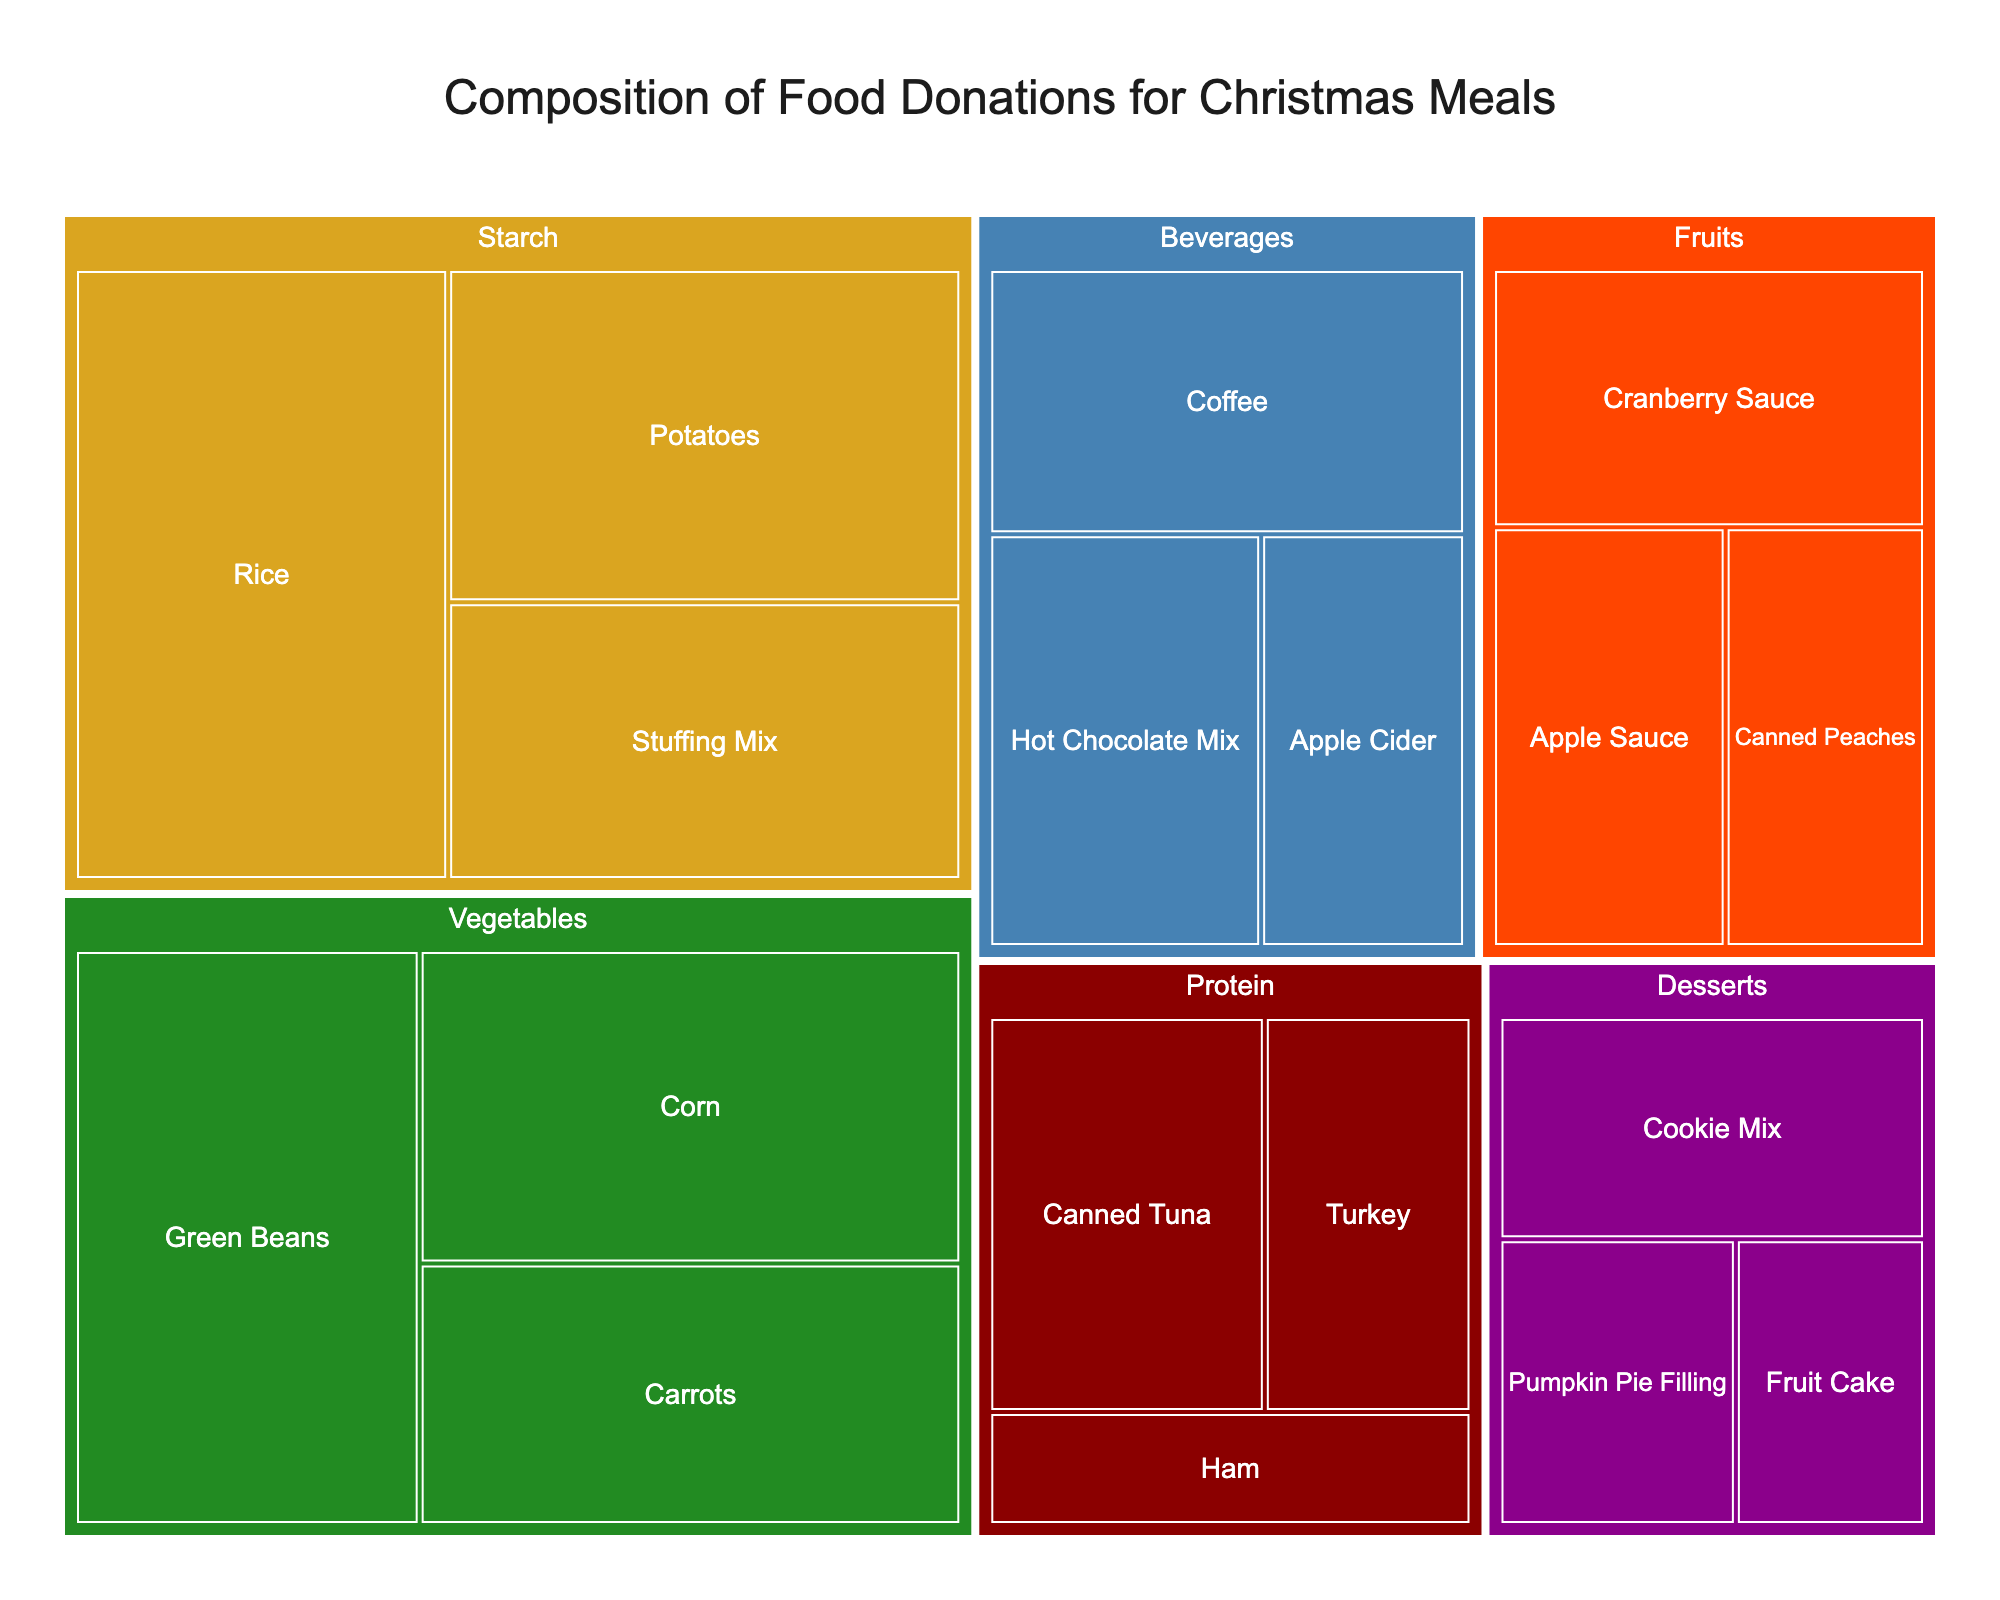What are the main categories of the donated food items? The treemap is organized into color-coded main categories: Protein, Starch, Vegetables, Fruits, Desserts, and Beverages. These categories are visually distinct by different colors.
Answer: Protein, Starch, Vegetables, Fruits, Desserts, Beverages Which food item has the highest quantity? Look at the largest segment in the treemap; it's the section with the label "Rice" in the Starch category.
Answer: Rice What is the combined quantity of 'Green Beans' and 'Carrots'? In the Vegetables category, 'Green Beans' has a quantity of 350 and 'Carrots' has 250. Add these quantities together: 350 + 250 = 600.
Answer: 600 Which category has the smallest quantity of items overall? The categories are visually distinguished by their combined area. 'Desserts' appears to have the smallest combined area in the treemap, suggesting it has the smallest total quantity.
Answer: Desserts Compare the quantities of 'Turkey' and 'Ham'. Which is greater and by how much? In the Protein category, 'Turkey' has a quantity of 150, and 'Ham' has 100. Subtract 100 from 150 to find the difference.
Answer: Turkey by 50 What is the total quantity of beverages donated? Add the quantities of all items in the Beverages category: 'Apple Cider' (150) + 'Hot Chocolate Mix' (200) + 'Coffee' (225). So, 150 + 200 + 225 = 575.
Answer: 575 How does the quantity of 'Apple Sauce' compare to 'Canned Peaches'? 'Apple Sauce' has a quantity of 175 and 'Canned Peaches' has 150 in the Fruits category. 175 is greater than 150.
Answer: Apple Sauce is greater Which category contributes most to the overall donations? Look at the areas of the categories in the treemap. The category with the largest area is 'Starch', so it contributes the most.
Answer: Starch What is the most common food item in the Fruits category by quantity? Within the Fruits category, 'Cranberry Sauce', 'Canned Peaches', and 'Apple Sauce' are present. 'Cranberry Sauce' has the highest quantity of 200.
Answer: Cranberry Sauce Which beverage item has the second highest quantity? In the Beverages category, 'Coffee' has the highest quantity at 225, followed by 'Hot Chocolate Mix' at 200.
Answer: Hot Chocolate Mix 